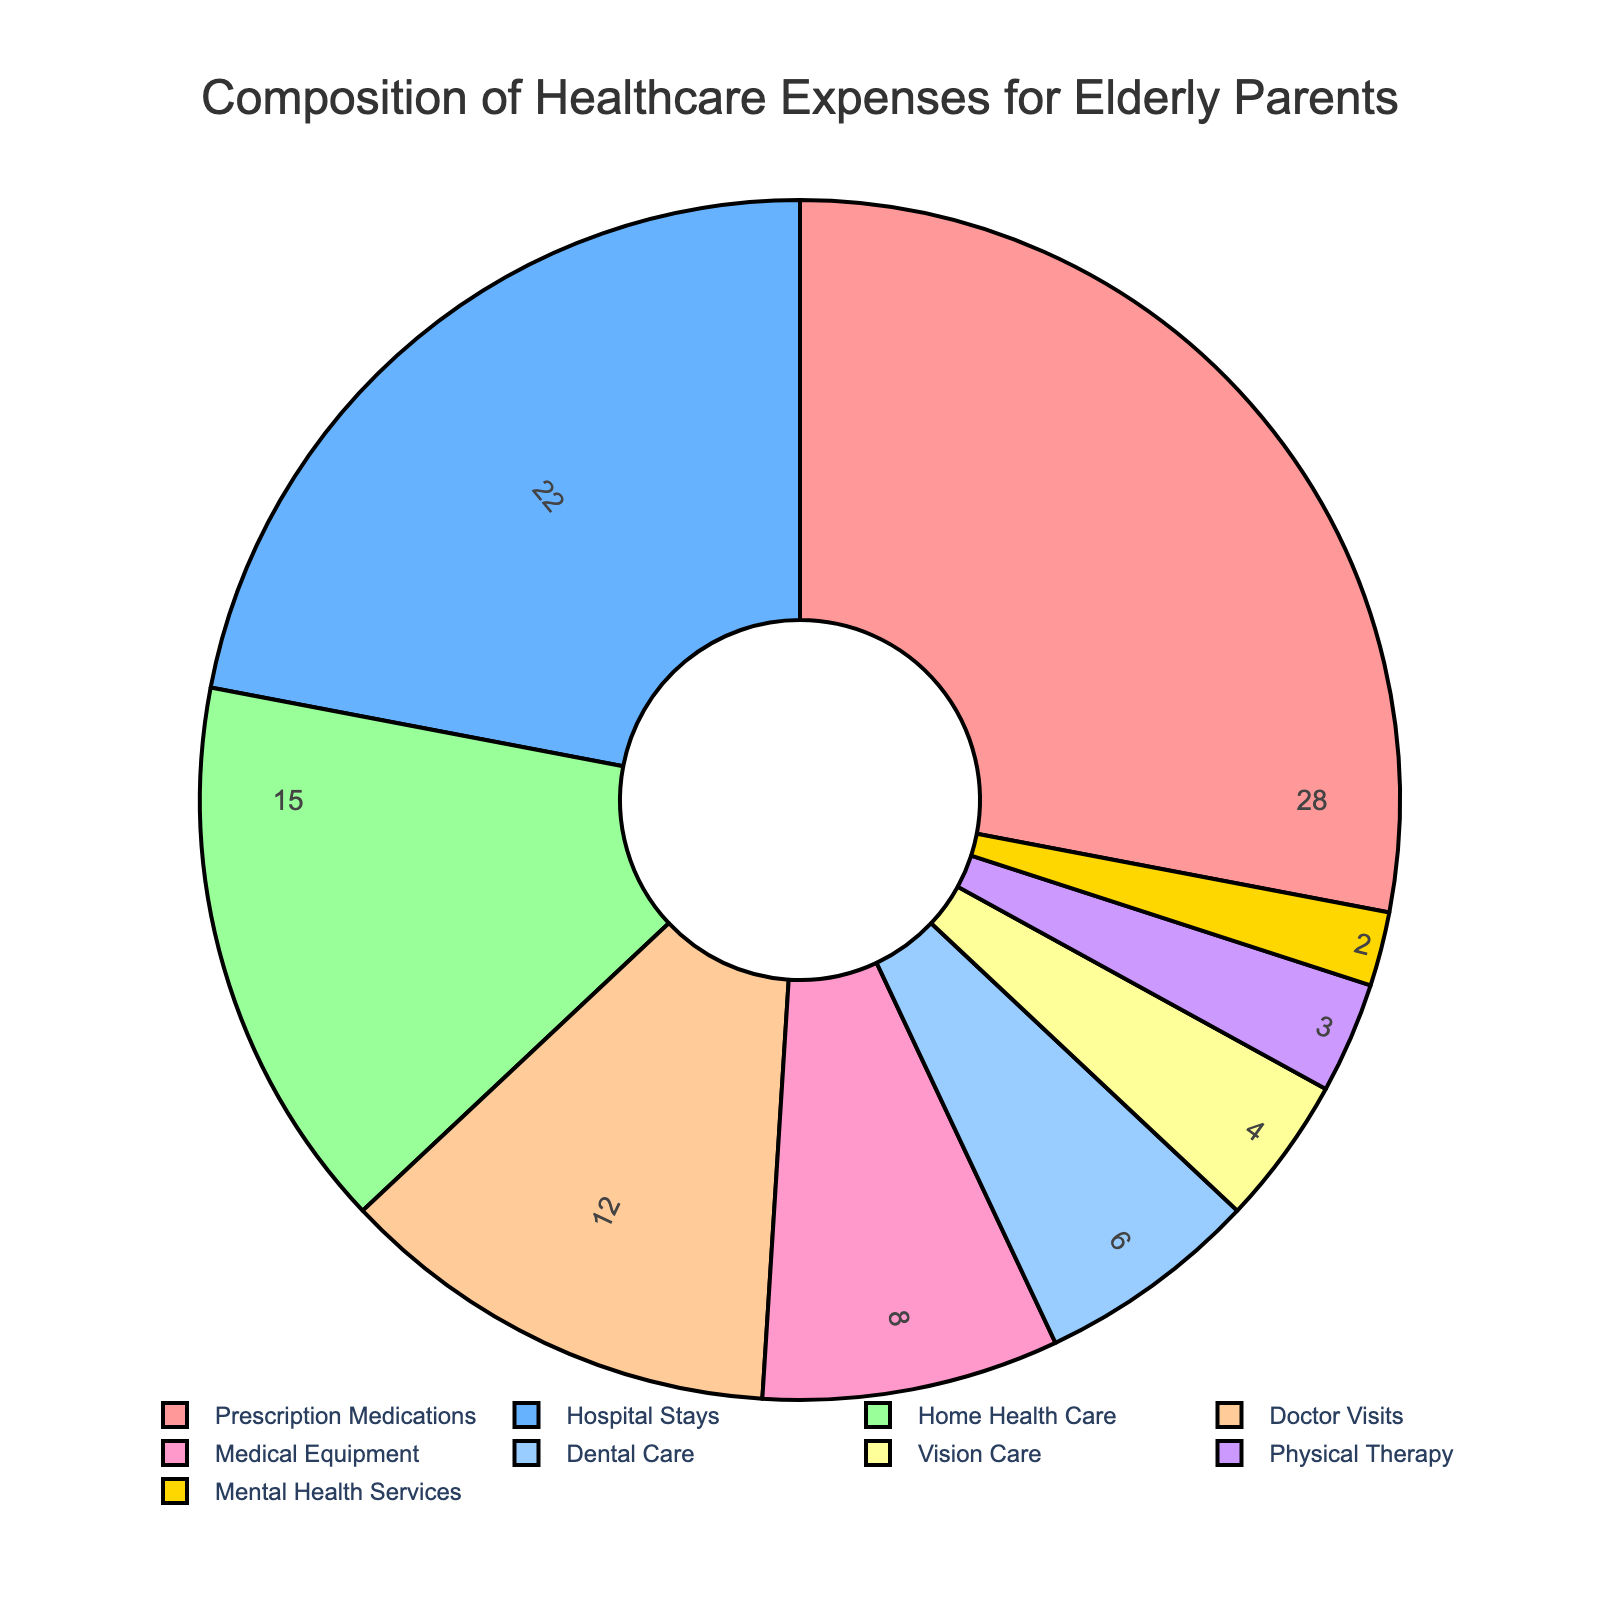What percentage of healthcare expenses does Prescription Medications represent? Refer to the slice labeled "Prescription Medications" and note the percentage.
Answer: 28% Which category accounts for more expenses: Hospital Stays or Home Health Care? Compare the percentages for "Hospital Stays" and "Home Health Care". Hospital Stays is 22%, and Home Health Care is 15%.
Answer: Hospital Stays What are the combined expenses for Vision Care and Mental Health Services? Add the percentages for "Vision Care" and "Mental Health Services". 4% + 2% = 6%
Answer: 6% Is the percentage of expenses for Doctor Visits higher or lower than Dental Care? Compare the percentages for "Doctor Visits" and "Dental Care". Doctor Visits is 12%, and Dental Care is 6%.
Answer: Higher What is the second largest category of healthcare expenses? Identify the category with the second highest percentage. Prescription Medications is highest, and Hospital Stays is second at 22%.
Answer: Hospital Stays What is the total percentage of expenses for categories other than Prescription Medications? Subtract the percentage for Prescription Medications from 100%. 100% - 28% = 72%
Answer: 72% Which color represents the Medical Equipment category? Look at the color corresponding to the Medical Equipment pie slice.
Answer: Blue-green What is the difference in percentage between Home Health Care and Physical Therapy? Subtract the percentage for Physical Therapy from Home Health Care. 15% - 3% = 12%
Answer: 12% If the expenses for Dental Care and Vision Care were combined, would their percentage exceed that of Home Health Care? Add the percentages for Dental Care and Vision Care and compare to Home Health Care. 6% + 4% = 10%, which is less than 15%.
Answer: No 